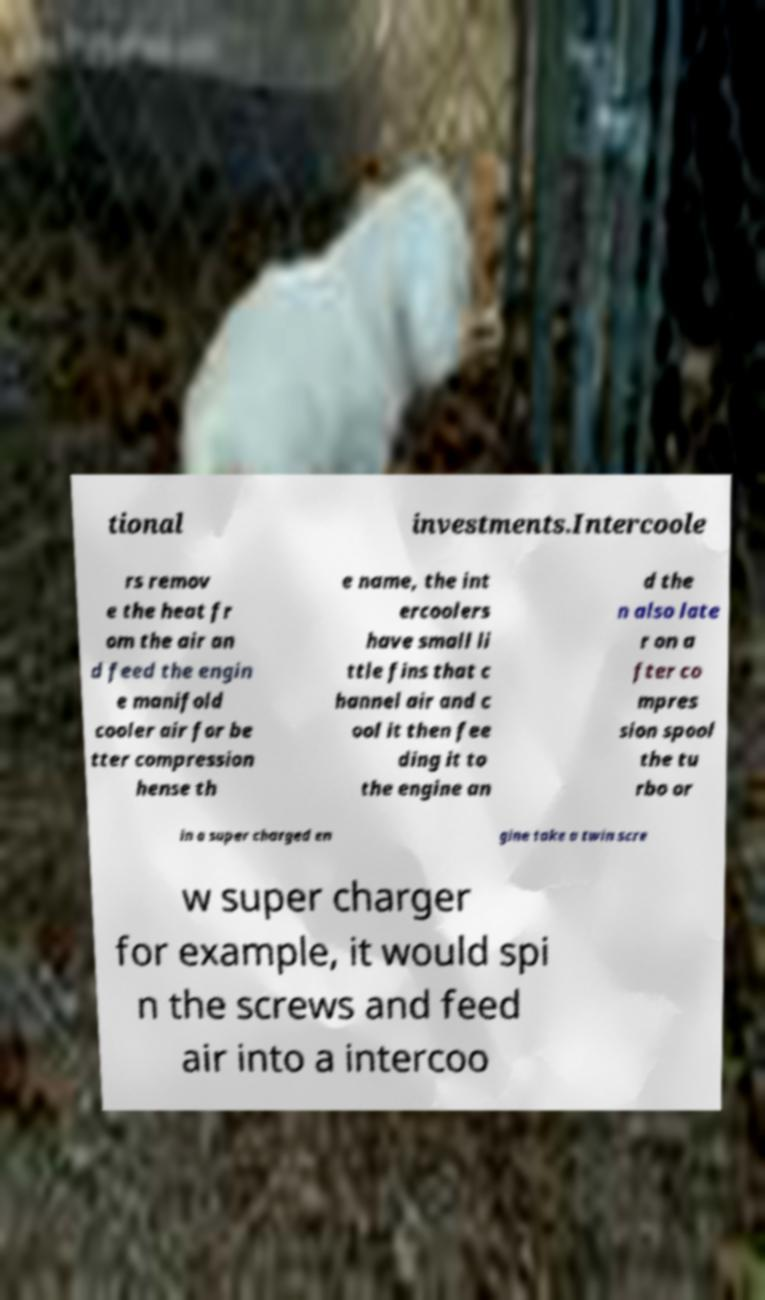Can you read and provide the text displayed in the image?This photo seems to have some interesting text. Can you extract and type it out for me? tional investments.Intercoole rs remov e the heat fr om the air an d feed the engin e manifold cooler air for be tter compression hense th e name, the int ercoolers have small li ttle fins that c hannel air and c ool it then fee ding it to the engine an d the n also late r on a fter co mpres sion spool the tu rbo or in a super charged en gine take a twin scre w super charger for example, it would spi n the screws and feed air into a intercoo 